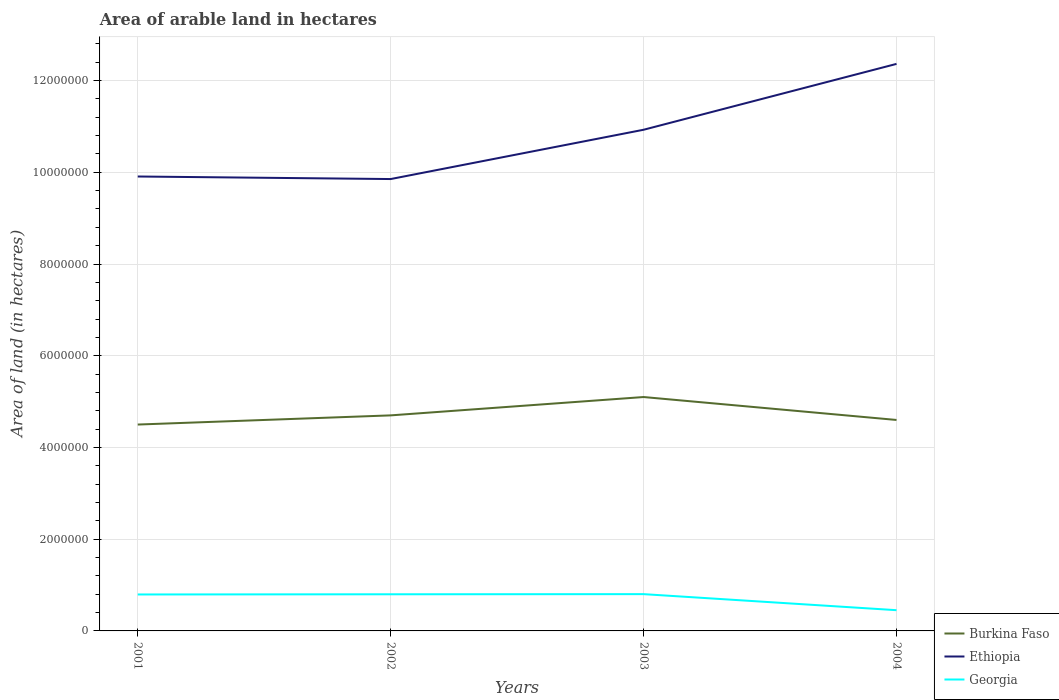How many different coloured lines are there?
Your response must be concise. 3. Is the number of lines equal to the number of legend labels?
Make the answer very short. Yes. Across all years, what is the maximum total arable land in Georgia?
Provide a short and direct response. 4.52e+05. In which year was the total arable land in Burkina Faso maximum?
Ensure brevity in your answer.  2001. What is the total total arable land in Burkina Faso in the graph?
Keep it short and to the point. 5.00e+05. Is the total arable land in Ethiopia strictly greater than the total arable land in Georgia over the years?
Your response must be concise. No. How many lines are there?
Ensure brevity in your answer.  3. How many years are there in the graph?
Your answer should be compact. 4. What is the difference between two consecutive major ticks on the Y-axis?
Keep it short and to the point. 2.00e+06. Does the graph contain any zero values?
Your answer should be very brief. No. Where does the legend appear in the graph?
Keep it short and to the point. Bottom right. How many legend labels are there?
Ensure brevity in your answer.  3. What is the title of the graph?
Provide a succinct answer. Area of arable land in hectares. What is the label or title of the Y-axis?
Offer a very short reply. Area of land (in hectares). What is the Area of land (in hectares) in Burkina Faso in 2001?
Offer a very short reply. 4.50e+06. What is the Area of land (in hectares) of Ethiopia in 2001?
Keep it short and to the point. 9.91e+06. What is the Area of land (in hectares) of Georgia in 2001?
Keep it short and to the point. 7.95e+05. What is the Area of land (in hectares) of Burkina Faso in 2002?
Provide a short and direct response. 4.70e+06. What is the Area of land (in hectares) in Ethiopia in 2002?
Provide a short and direct response. 9.85e+06. What is the Area of land (in hectares) of Georgia in 2002?
Offer a terse response. 7.99e+05. What is the Area of land (in hectares) in Burkina Faso in 2003?
Offer a very short reply. 5.10e+06. What is the Area of land (in hectares) of Ethiopia in 2003?
Your response must be concise. 1.09e+07. What is the Area of land (in hectares) in Georgia in 2003?
Make the answer very short. 8.02e+05. What is the Area of land (in hectares) in Burkina Faso in 2004?
Provide a short and direct response. 4.60e+06. What is the Area of land (in hectares) of Ethiopia in 2004?
Keep it short and to the point. 1.24e+07. What is the Area of land (in hectares) in Georgia in 2004?
Provide a succinct answer. 4.52e+05. Across all years, what is the maximum Area of land (in hectares) of Burkina Faso?
Give a very brief answer. 5.10e+06. Across all years, what is the maximum Area of land (in hectares) in Ethiopia?
Your answer should be very brief. 1.24e+07. Across all years, what is the maximum Area of land (in hectares) in Georgia?
Provide a succinct answer. 8.02e+05. Across all years, what is the minimum Area of land (in hectares) of Burkina Faso?
Offer a terse response. 4.50e+06. Across all years, what is the minimum Area of land (in hectares) of Ethiopia?
Provide a succinct answer. 9.85e+06. Across all years, what is the minimum Area of land (in hectares) of Georgia?
Your answer should be very brief. 4.52e+05. What is the total Area of land (in hectares) in Burkina Faso in the graph?
Keep it short and to the point. 1.89e+07. What is the total Area of land (in hectares) of Ethiopia in the graph?
Give a very brief answer. 4.31e+07. What is the total Area of land (in hectares) in Georgia in the graph?
Your response must be concise. 2.85e+06. What is the difference between the Area of land (in hectares) in Burkina Faso in 2001 and that in 2002?
Provide a short and direct response. -2.00e+05. What is the difference between the Area of land (in hectares) of Ethiopia in 2001 and that in 2002?
Offer a terse response. 5.54e+04. What is the difference between the Area of land (in hectares) in Georgia in 2001 and that in 2002?
Provide a succinct answer. -4000. What is the difference between the Area of land (in hectares) in Burkina Faso in 2001 and that in 2003?
Your answer should be very brief. -6.00e+05. What is the difference between the Area of land (in hectares) of Ethiopia in 2001 and that in 2003?
Your answer should be compact. -1.02e+06. What is the difference between the Area of land (in hectares) of Georgia in 2001 and that in 2003?
Offer a very short reply. -7000. What is the difference between the Area of land (in hectares) of Burkina Faso in 2001 and that in 2004?
Ensure brevity in your answer.  -1.00e+05. What is the difference between the Area of land (in hectares) of Ethiopia in 2001 and that in 2004?
Give a very brief answer. -2.46e+06. What is the difference between the Area of land (in hectares) of Georgia in 2001 and that in 2004?
Provide a short and direct response. 3.43e+05. What is the difference between the Area of land (in hectares) of Burkina Faso in 2002 and that in 2003?
Give a very brief answer. -4.00e+05. What is the difference between the Area of land (in hectares) in Ethiopia in 2002 and that in 2003?
Your answer should be compact. -1.08e+06. What is the difference between the Area of land (in hectares) in Georgia in 2002 and that in 2003?
Provide a short and direct response. -3000. What is the difference between the Area of land (in hectares) in Ethiopia in 2002 and that in 2004?
Ensure brevity in your answer.  -2.51e+06. What is the difference between the Area of land (in hectares) in Georgia in 2002 and that in 2004?
Your response must be concise. 3.47e+05. What is the difference between the Area of land (in hectares) of Burkina Faso in 2003 and that in 2004?
Offer a terse response. 5.00e+05. What is the difference between the Area of land (in hectares) of Ethiopia in 2003 and that in 2004?
Your answer should be very brief. -1.44e+06. What is the difference between the Area of land (in hectares) of Georgia in 2003 and that in 2004?
Provide a short and direct response. 3.50e+05. What is the difference between the Area of land (in hectares) in Burkina Faso in 2001 and the Area of land (in hectares) in Ethiopia in 2002?
Ensure brevity in your answer.  -5.35e+06. What is the difference between the Area of land (in hectares) of Burkina Faso in 2001 and the Area of land (in hectares) of Georgia in 2002?
Give a very brief answer. 3.70e+06. What is the difference between the Area of land (in hectares) in Ethiopia in 2001 and the Area of land (in hectares) in Georgia in 2002?
Make the answer very short. 9.11e+06. What is the difference between the Area of land (in hectares) of Burkina Faso in 2001 and the Area of land (in hectares) of Ethiopia in 2003?
Make the answer very short. -6.43e+06. What is the difference between the Area of land (in hectares) in Burkina Faso in 2001 and the Area of land (in hectares) in Georgia in 2003?
Your answer should be compact. 3.70e+06. What is the difference between the Area of land (in hectares) in Ethiopia in 2001 and the Area of land (in hectares) in Georgia in 2003?
Keep it short and to the point. 9.11e+06. What is the difference between the Area of land (in hectares) of Burkina Faso in 2001 and the Area of land (in hectares) of Ethiopia in 2004?
Provide a succinct answer. -7.86e+06. What is the difference between the Area of land (in hectares) of Burkina Faso in 2001 and the Area of land (in hectares) of Georgia in 2004?
Make the answer very short. 4.05e+06. What is the difference between the Area of land (in hectares) in Ethiopia in 2001 and the Area of land (in hectares) in Georgia in 2004?
Give a very brief answer. 9.46e+06. What is the difference between the Area of land (in hectares) in Burkina Faso in 2002 and the Area of land (in hectares) in Ethiopia in 2003?
Provide a succinct answer. -6.23e+06. What is the difference between the Area of land (in hectares) of Burkina Faso in 2002 and the Area of land (in hectares) of Georgia in 2003?
Ensure brevity in your answer.  3.90e+06. What is the difference between the Area of land (in hectares) in Ethiopia in 2002 and the Area of land (in hectares) in Georgia in 2003?
Make the answer very short. 9.05e+06. What is the difference between the Area of land (in hectares) in Burkina Faso in 2002 and the Area of land (in hectares) in Ethiopia in 2004?
Provide a succinct answer. -7.66e+06. What is the difference between the Area of land (in hectares) of Burkina Faso in 2002 and the Area of land (in hectares) of Georgia in 2004?
Your response must be concise. 4.25e+06. What is the difference between the Area of land (in hectares) of Ethiopia in 2002 and the Area of land (in hectares) of Georgia in 2004?
Make the answer very short. 9.40e+06. What is the difference between the Area of land (in hectares) of Burkina Faso in 2003 and the Area of land (in hectares) of Ethiopia in 2004?
Provide a short and direct response. -7.26e+06. What is the difference between the Area of land (in hectares) of Burkina Faso in 2003 and the Area of land (in hectares) of Georgia in 2004?
Provide a short and direct response. 4.65e+06. What is the difference between the Area of land (in hectares) of Ethiopia in 2003 and the Area of land (in hectares) of Georgia in 2004?
Give a very brief answer. 1.05e+07. What is the average Area of land (in hectares) of Burkina Faso per year?
Make the answer very short. 4.72e+06. What is the average Area of land (in hectares) of Ethiopia per year?
Provide a short and direct response. 1.08e+07. What is the average Area of land (in hectares) in Georgia per year?
Offer a very short reply. 7.12e+05. In the year 2001, what is the difference between the Area of land (in hectares) of Burkina Faso and Area of land (in hectares) of Ethiopia?
Offer a terse response. -5.41e+06. In the year 2001, what is the difference between the Area of land (in hectares) in Burkina Faso and Area of land (in hectares) in Georgia?
Ensure brevity in your answer.  3.70e+06. In the year 2001, what is the difference between the Area of land (in hectares) in Ethiopia and Area of land (in hectares) in Georgia?
Offer a very short reply. 9.11e+06. In the year 2002, what is the difference between the Area of land (in hectares) in Burkina Faso and Area of land (in hectares) in Ethiopia?
Your response must be concise. -5.15e+06. In the year 2002, what is the difference between the Area of land (in hectares) of Burkina Faso and Area of land (in hectares) of Georgia?
Ensure brevity in your answer.  3.90e+06. In the year 2002, what is the difference between the Area of land (in hectares) in Ethiopia and Area of land (in hectares) in Georgia?
Provide a succinct answer. 9.05e+06. In the year 2003, what is the difference between the Area of land (in hectares) of Burkina Faso and Area of land (in hectares) of Ethiopia?
Your response must be concise. -5.83e+06. In the year 2003, what is the difference between the Area of land (in hectares) in Burkina Faso and Area of land (in hectares) in Georgia?
Keep it short and to the point. 4.30e+06. In the year 2003, what is the difference between the Area of land (in hectares) in Ethiopia and Area of land (in hectares) in Georgia?
Your answer should be very brief. 1.01e+07. In the year 2004, what is the difference between the Area of land (in hectares) of Burkina Faso and Area of land (in hectares) of Ethiopia?
Give a very brief answer. -7.76e+06. In the year 2004, what is the difference between the Area of land (in hectares) of Burkina Faso and Area of land (in hectares) of Georgia?
Keep it short and to the point. 4.15e+06. In the year 2004, what is the difference between the Area of land (in hectares) in Ethiopia and Area of land (in hectares) in Georgia?
Offer a terse response. 1.19e+07. What is the ratio of the Area of land (in hectares) in Burkina Faso in 2001 to that in 2002?
Ensure brevity in your answer.  0.96. What is the ratio of the Area of land (in hectares) in Ethiopia in 2001 to that in 2002?
Your answer should be very brief. 1.01. What is the ratio of the Area of land (in hectares) in Georgia in 2001 to that in 2002?
Your answer should be very brief. 0.99. What is the ratio of the Area of land (in hectares) of Burkina Faso in 2001 to that in 2003?
Your response must be concise. 0.88. What is the ratio of the Area of land (in hectares) in Ethiopia in 2001 to that in 2003?
Offer a very short reply. 0.91. What is the ratio of the Area of land (in hectares) in Burkina Faso in 2001 to that in 2004?
Your answer should be compact. 0.98. What is the ratio of the Area of land (in hectares) of Ethiopia in 2001 to that in 2004?
Give a very brief answer. 0.8. What is the ratio of the Area of land (in hectares) in Georgia in 2001 to that in 2004?
Your answer should be very brief. 1.76. What is the ratio of the Area of land (in hectares) of Burkina Faso in 2002 to that in 2003?
Offer a terse response. 0.92. What is the ratio of the Area of land (in hectares) of Ethiopia in 2002 to that in 2003?
Ensure brevity in your answer.  0.9. What is the ratio of the Area of land (in hectares) of Burkina Faso in 2002 to that in 2004?
Your answer should be very brief. 1.02. What is the ratio of the Area of land (in hectares) of Ethiopia in 2002 to that in 2004?
Offer a terse response. 0.8. What is the ratio of the Area of land (in hectares) of Georgia in 2002 to that in 2004?
Make the answer very short. 1.77. What is the ratio of the Area of land (in hectares) in Burkina Faso in 2003 to that in 2004?
Make the answer very short. 1.11. What is the ratio of the Area of land (in hectares) in Ethiopia in 2003 to that in 2004?
Offer a very short reply. 0.88. What is the ratio of the Area of land (in hectares) of Georgia in 2003 to that in 2004?
Keep it short and to the point. 1.77. What is the difference between the highest and the second highest Area of land (in hectares) of Burkina Faso?
Your answer should be very brief. 4.00e+05. What is the difference between the highest and the second highest Area of land (in hectares) of Ethiopia?
Your answer should be very brief. 1.44e+06. What is the difference between the highest and the second highest Area of land (in hectares) of Georgia?
Your response must be concise. 3000. What is the difference between the highest and the lowest Area of land (in hectares) in Burkina Faso?
Make the answer very short. 6.00e+05. What is the difference between the highest and the lowest Area of land (in hectares) of Ethiopia?
Offer a very short reply. 2.51e+06. 